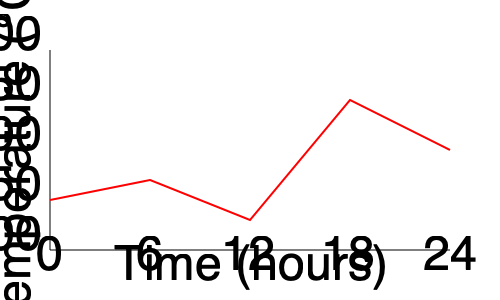Given the time-series graph of chemical reactor temperatures over a 24-hour period, what is the most likely cause of the sharp temperature increase between hours 12 and 18, and what immediate action should be taken as a supervisor? To answer this question, we need to analyze the graph and consider potential causes for temperature fluctuations in chemical reactors:

1. Observe the overall trend: The temperature fluctuates between approximately 150°C and 250°C over the 24-hour period.

2. Identify the sharp increase: Between hours 12 and 18, there's a significant temperature rise from about 180°C to 270°C.

3. Consider possible causes for such a rapid increase:
   a) Exothermic reaction acceleration
   b) Cooling system failure
   c) Incorrect reactant addition
   d) Control system malfunction

4. Evaluate the most likely cause: Given the suddenness and magnitude of the increase, a cooling system failure is the most probable cause. Exothermic reactions typically don't cause such rapid changes, and incorrect reactant addition or control system issues usually result in more gradual changes.

5. Determine immediate action: As a supervisor, the priority is to ensure safety and prevent potential runaway reactions. The immediate action should be to initiate emergency cooling procedures to bring the temperature down and prevent further escalation.

6. Long-term action: After stabilizing the temperature, investigate the root cause of the cooling system failure and implement corrective measures to prevent future occurrences.
Answer: Likely cause: Cooling system failure. Immediate action: Initiate emergency cooling procedures. 